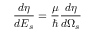Convert formula to latex. <formula><loc_0><loc_0><loc_500><loc_500>\frac { d \eta } { d E _ { s } } = \frac { \mu } { } \frac { d \eta } { d \Omega _ { s } }</formula> 